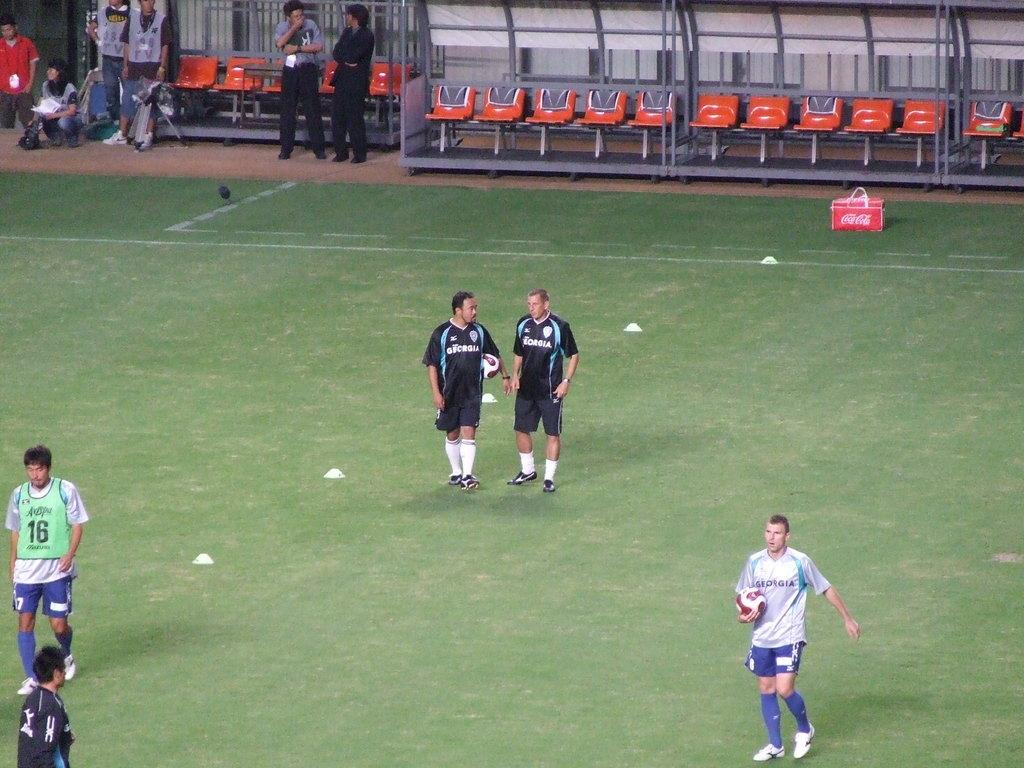Provide a one-sentence caption for the provided image. The cooler is carrying the soda coca cola inside. 